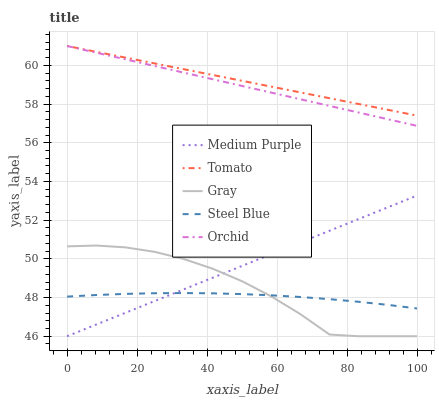Does Steel Blue have the minimum area under the curve?
Answer yes or no. Yes. Does Tomato have the maximum area under the curve?
Answer yes or no. Yes. Does Orchid have the minimum area under the curve?
Answer yes or no. No. Does Orchid have the maximum area under the curve?
Answer yes or no. No. Is Orchid the smoothest?
Answer yes or no. Yes. Is Gray the roughest?
Answer yes or no. Yes. Is Tomato the smoothest?
Answer yes or no. No. Is Tomato the roughest?
Answer yes or no. No. Does Medium Purple have the lowest value?
Answer yes or no. Yes. Does Orchid have the lowest value?
Answer yes or no. No. Does Orchid have the highest value?
Answer yes or no. Yes. Does Steel Blue have the highest value?
Answer yes or no. No. Is Gray less than Tomato?
Answer yes or no. Yes. Is Tomato greater than Steel Blue?
Answer yes or no. Yes. Does Gray intersect Medium Purple?
Answer yes or no. Yes. Is Gray less than Medium Purple?
Answer yes or no. No. Is Gray greater than Medium Purple?
Answer yes or no. No. Does Gray intersect Tomato?
Answer yes or no. No. 